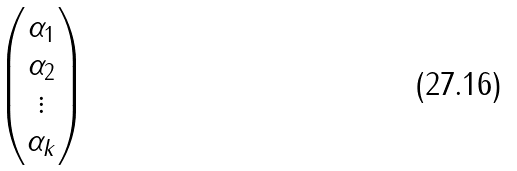<formula> <loc_0><loc_0><loc_500><loc_500>\begin{pmatrix} \alpha _ { 1 } \\ \alpha _ { 2 } \\ \vdots \\ \alpha _ { k } \end{pmatrix}</formula> 